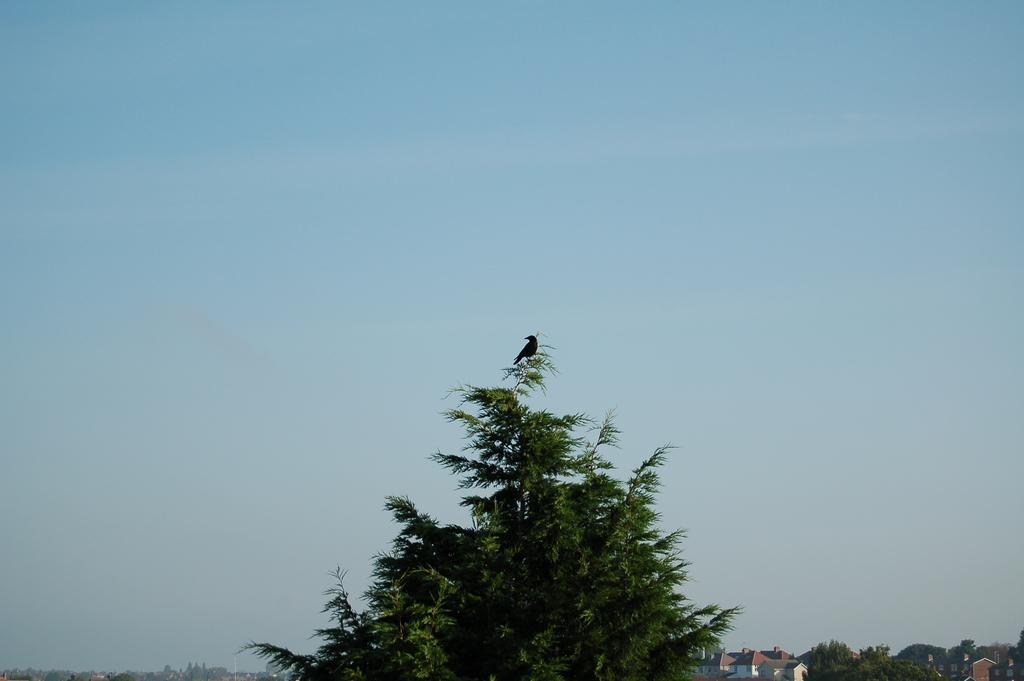What is the main object in the foreground of the image? There is a tree in the image. Is there any wildlife on the tree? Yes, a bird is present on the tree. What can be seen in the background of the image? There are houses and trees in the background of the image. What is the condition of the sky in the image? The sky is visible at the top of the image, and it is clear. What type of fruit is hanging from the branches of the tree in the image? There is no fruit visible on the tree in the image. Are there any books on the branches of the tree in the image? No, there are no books present on the tree or anywhere else in the image. 